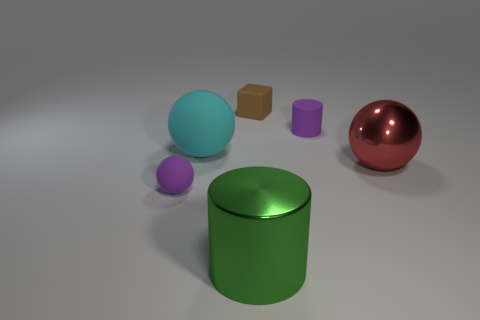How do the shapes of these objects affect their spatial presence? The spherical objects have a continuous surface with no edges and may appear softer and more approachable, while the cube’s sharp edges give it a more solid and stable presence. The cylinders bridge these two impressions with their curved sides and flat ends. Which of these objects would be most efficient to pack in a box without wasted space? The cube would be the most efficient to pack due to its regular shape, which aligns well with the straight edges of a box, minimizing wasted space compared to the curved surfaces of the spheres and cylinders. 